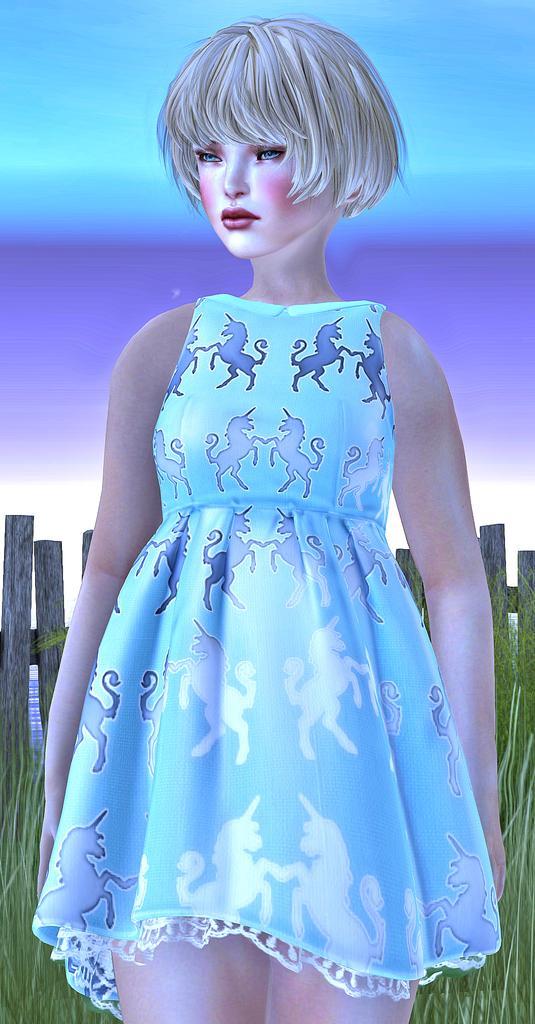In one or two sentences, can you explain what this image depicts? This is an animated picture and in this picture we can see a girl, grass and wooden sticks. 